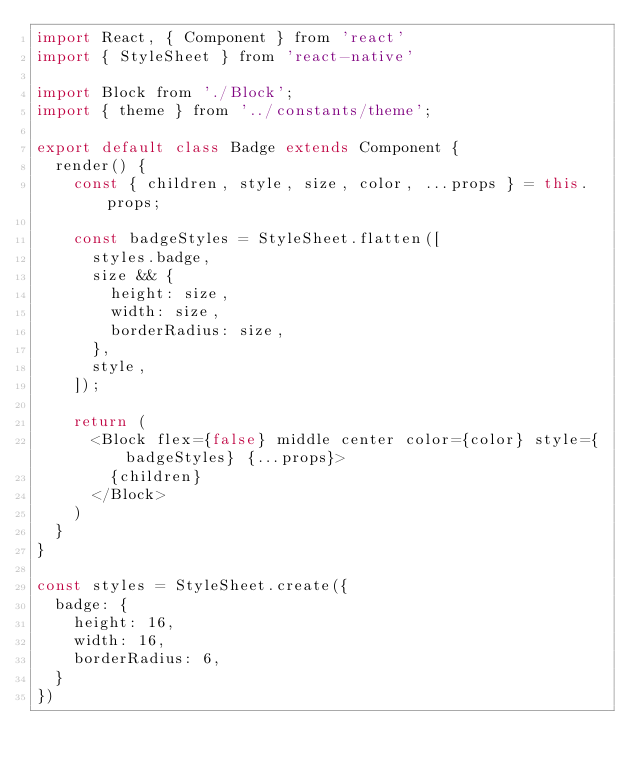<code> <loc_0><loc_0><loc_500><loc_500><_JavaScript_>import React, { Component } from 'react'
import { StyleSheet } from 'react-native'

import Block from './Block';
import { theme } from '../constants/theme';

export default class Badge extends Component {
  render() {
    const { children, style, size, color, ...props } = this.props;

    const badgeStyles = StyleSheet.flatten([
      styles.badge,
      size && {
        height: size,
        width: size,
        borderRadius: size,
      },
      style,
    ]);

    return (
      <Block flex={false} middle center color={color} style={badgeStyles} {...props}>
        {children}
      </Block>
    )
  }
}

const styles = StyleSheet.create({
  badge: {
    height: 16,
    width: 16,
    borderRadius: 6,
  }
})
</code> 